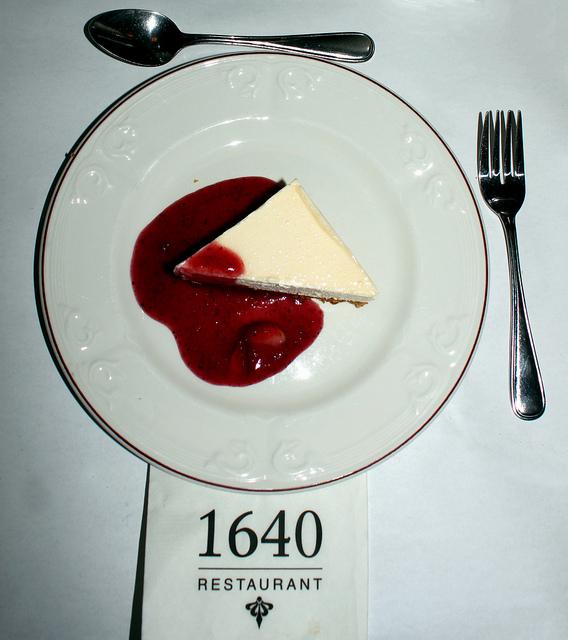Number is in the photo?
Write a very short answer. 1640. Has this dessert been served in a restaurant?
Write a very short answer. Yes. What kind of cake is this?
Short answer required. Cheesecake. 